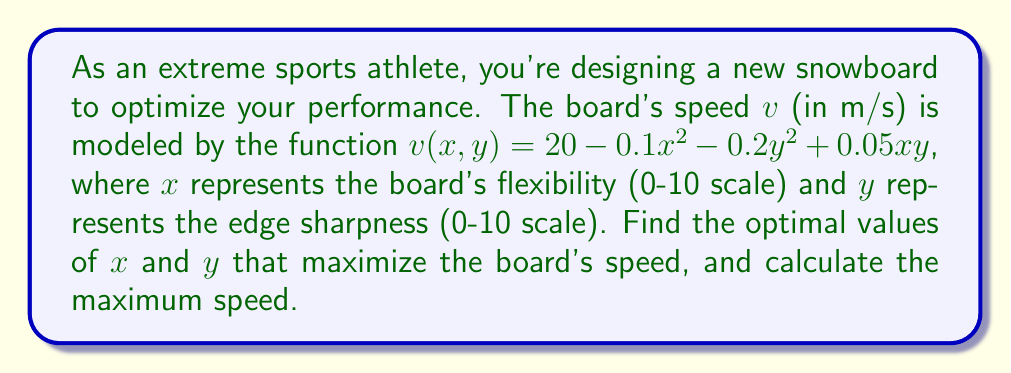Show me your answer to this math problem. To find the optimal values of $x$ and $y$ that maximize the speed, we need to find the critical points of the function $v(x,y)$. We'll use the following steps:

1. Calculate the partial derivatives of $v$ with respect to $x$ and $y$:
   $$\frac{\partial v}{\partial x} = -0.2x + 0.05y$$
   $$\frac{\partial v}{\partial y} = -0.4y + 0.05x$$

2. Set both partial derivatives equal to zero and solve the system of equations:
   $$-0.2x + 0.05y = 0$$
   $$-0.4y + 0.05x = 0$$

3. Multiply the first equation by 2 and the second equation by 1:
   $$-0.4x + 0.1y = 0$$
   $$-0.4y + 0.05x = 0$$

4. Add these equations to eliminate $y$:
   $$-0.35x = 0$$
   $$x = 0$$

5. Substitute $x = 0$ into either of the original equations:
   $$0.05y = 0$$
   $$y = 0$$

6. The critical point is $(0, 0)$. To confirm it's a maximum, we can check the second partial derivatives:
   $$\frac{\partial^2 v}{\partial x^2} = -0.2$$
   $$\frac{\partial^2 v}{\partial y^2} = -0.4$$
   $$\frac{\partial^2 v}{\partial x \partial y} = 0.05$$

   The Hessian matrix at $(0, 0)$ is:
   $$H = \begin{bmatrix} -0.2 & 0.05 \\ 0.05 & -0.4 \end{bmatrix}$$

   Since $\frac{\partial^2 v}{\partial x^2} < 0$ and $\det(H) = 0.0775 > 0$, the critical point is a local maximum.

7. Calculate the maximum speed by substituting $x = 0$ and $y = 0$ into the original function:
   $$v(0, 0) = 20 - 0.1(0)^2 - 0.2(0)^2 + 0.05(0)(0) = 20$$

Therefore, the optimal values are $x = 0$ (minimum flexibility) and $y = 0$ (minimum edge sharpness), and the maximum speed is 20 m/s.
Answer: $x = 0$, $y = 0$, $v_{max} = 20$ m/s 